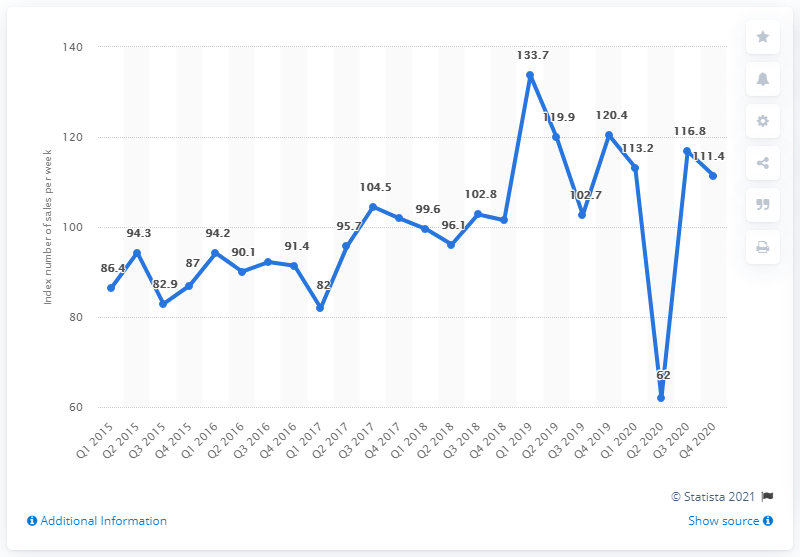Give some essential details in this illustration. In the first quarter of 2019, the peak sales volume of second-hand goods reached 133.7 million units. 